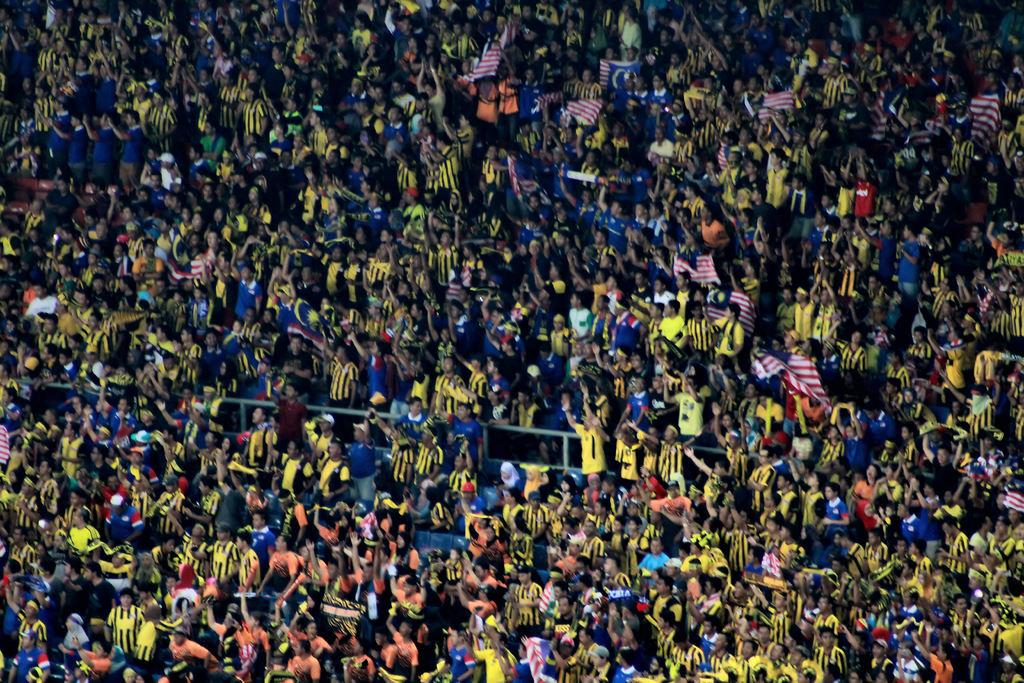What is present in the image? There are people, poles, and flags in the image. Can you describe the poles in the image? Yes, there are poles in the image. What is attached to the poles in the image? Flags are attached to the poles in the image. What type of club can be seen in the hands of the people in the image? There is no club present in the image; the people are not holding any clubs. How many turkeys are visible in the image? There are no turkeys present in the image. 